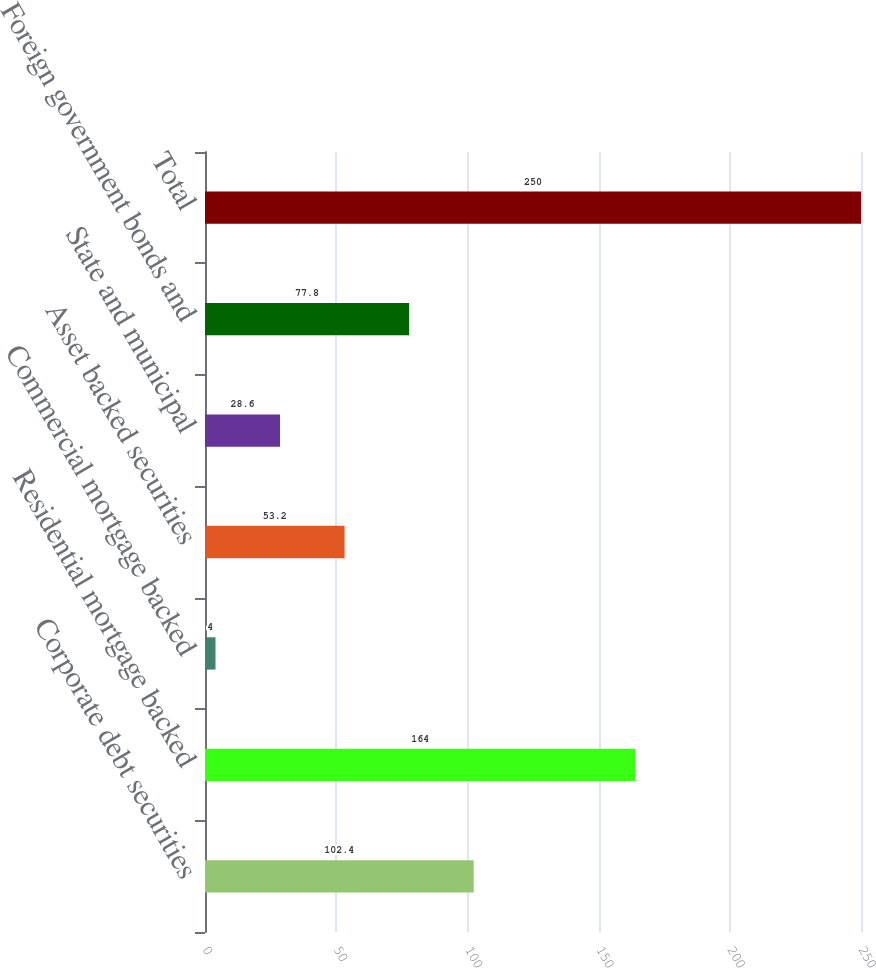Convert chart. <chart><loc_0><loc_0><loc_500><loc_500><bar_chart><fcel>Corporate debt securities<fcel>Residential mortgage backed<fcel>Commercial mortgage backed<fcel>Asset backed securities<fcel>State and municipal<fcel>Foreign government bonds and<fcel>Total<nl><fcel>102.4<fcel>164<fcel>4<fcel>53.2<fcel>28.6<fcel>77.8<fcel>250<nl></chart> 